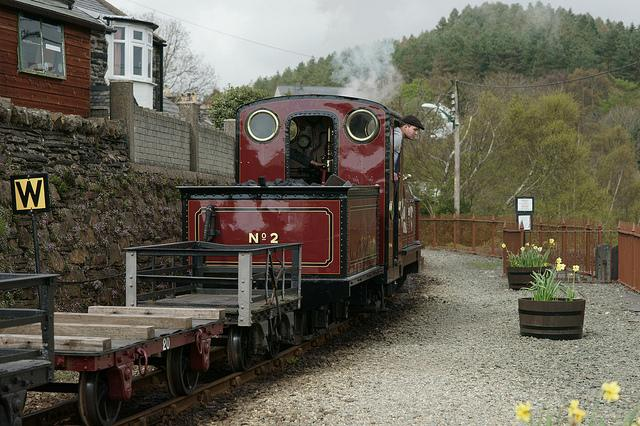Why are those flowers growing in those bins? decoration 